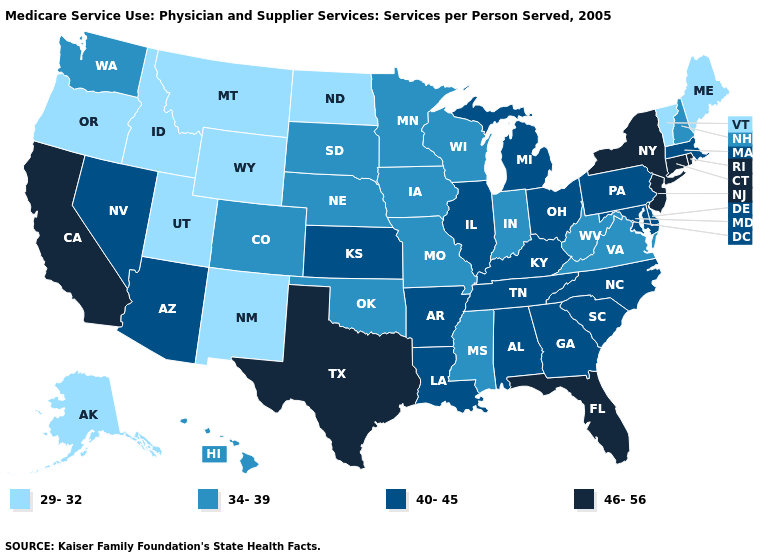What is the value of Massachusetts?
Short answer required. 40-45. Does New Mexico have the lowest value in the USA?
Concise answer only. Yes. Among the states that border Maine , which have the lowest value?
Answer briefly. New Hampshire. What is the value of Massachusetts?
Be succinct. 40-45. Does Georgia have a lower value than Rhode Island?
Short answer required. Yes. What is the value of Kansas?
Be succinct. 40-45. What is the value of Montana?
Short answer required. 29-32. What is the value of Wyoming?
Give a very brief answer. 29-32. What is the value of North Carolina?
Write a very short answer. 40-45. Name the states that have a value in the range 34-39?
Answer briefly. Colorado, Hawaii, Indiana, Iowa, Minnesota, Mississippi, Missouri, Nebraska, New Hampshire, Oklahoma, South Dakota, Virginia, Washington, West Virginia, Wisconsin. How many symbols are there in the legend?
Concise answer only. 4. Among the states that border Oregon , does Washington have the highest value?
Write a very short answer. No. Does Washington have the same value as Illinois?
Be succinct. No. Among the states that border Virginia , does Kentucky have the lowest value?
Give a very brief answer. No. Is the legend a continuous bar?
Concise answer only. No. 